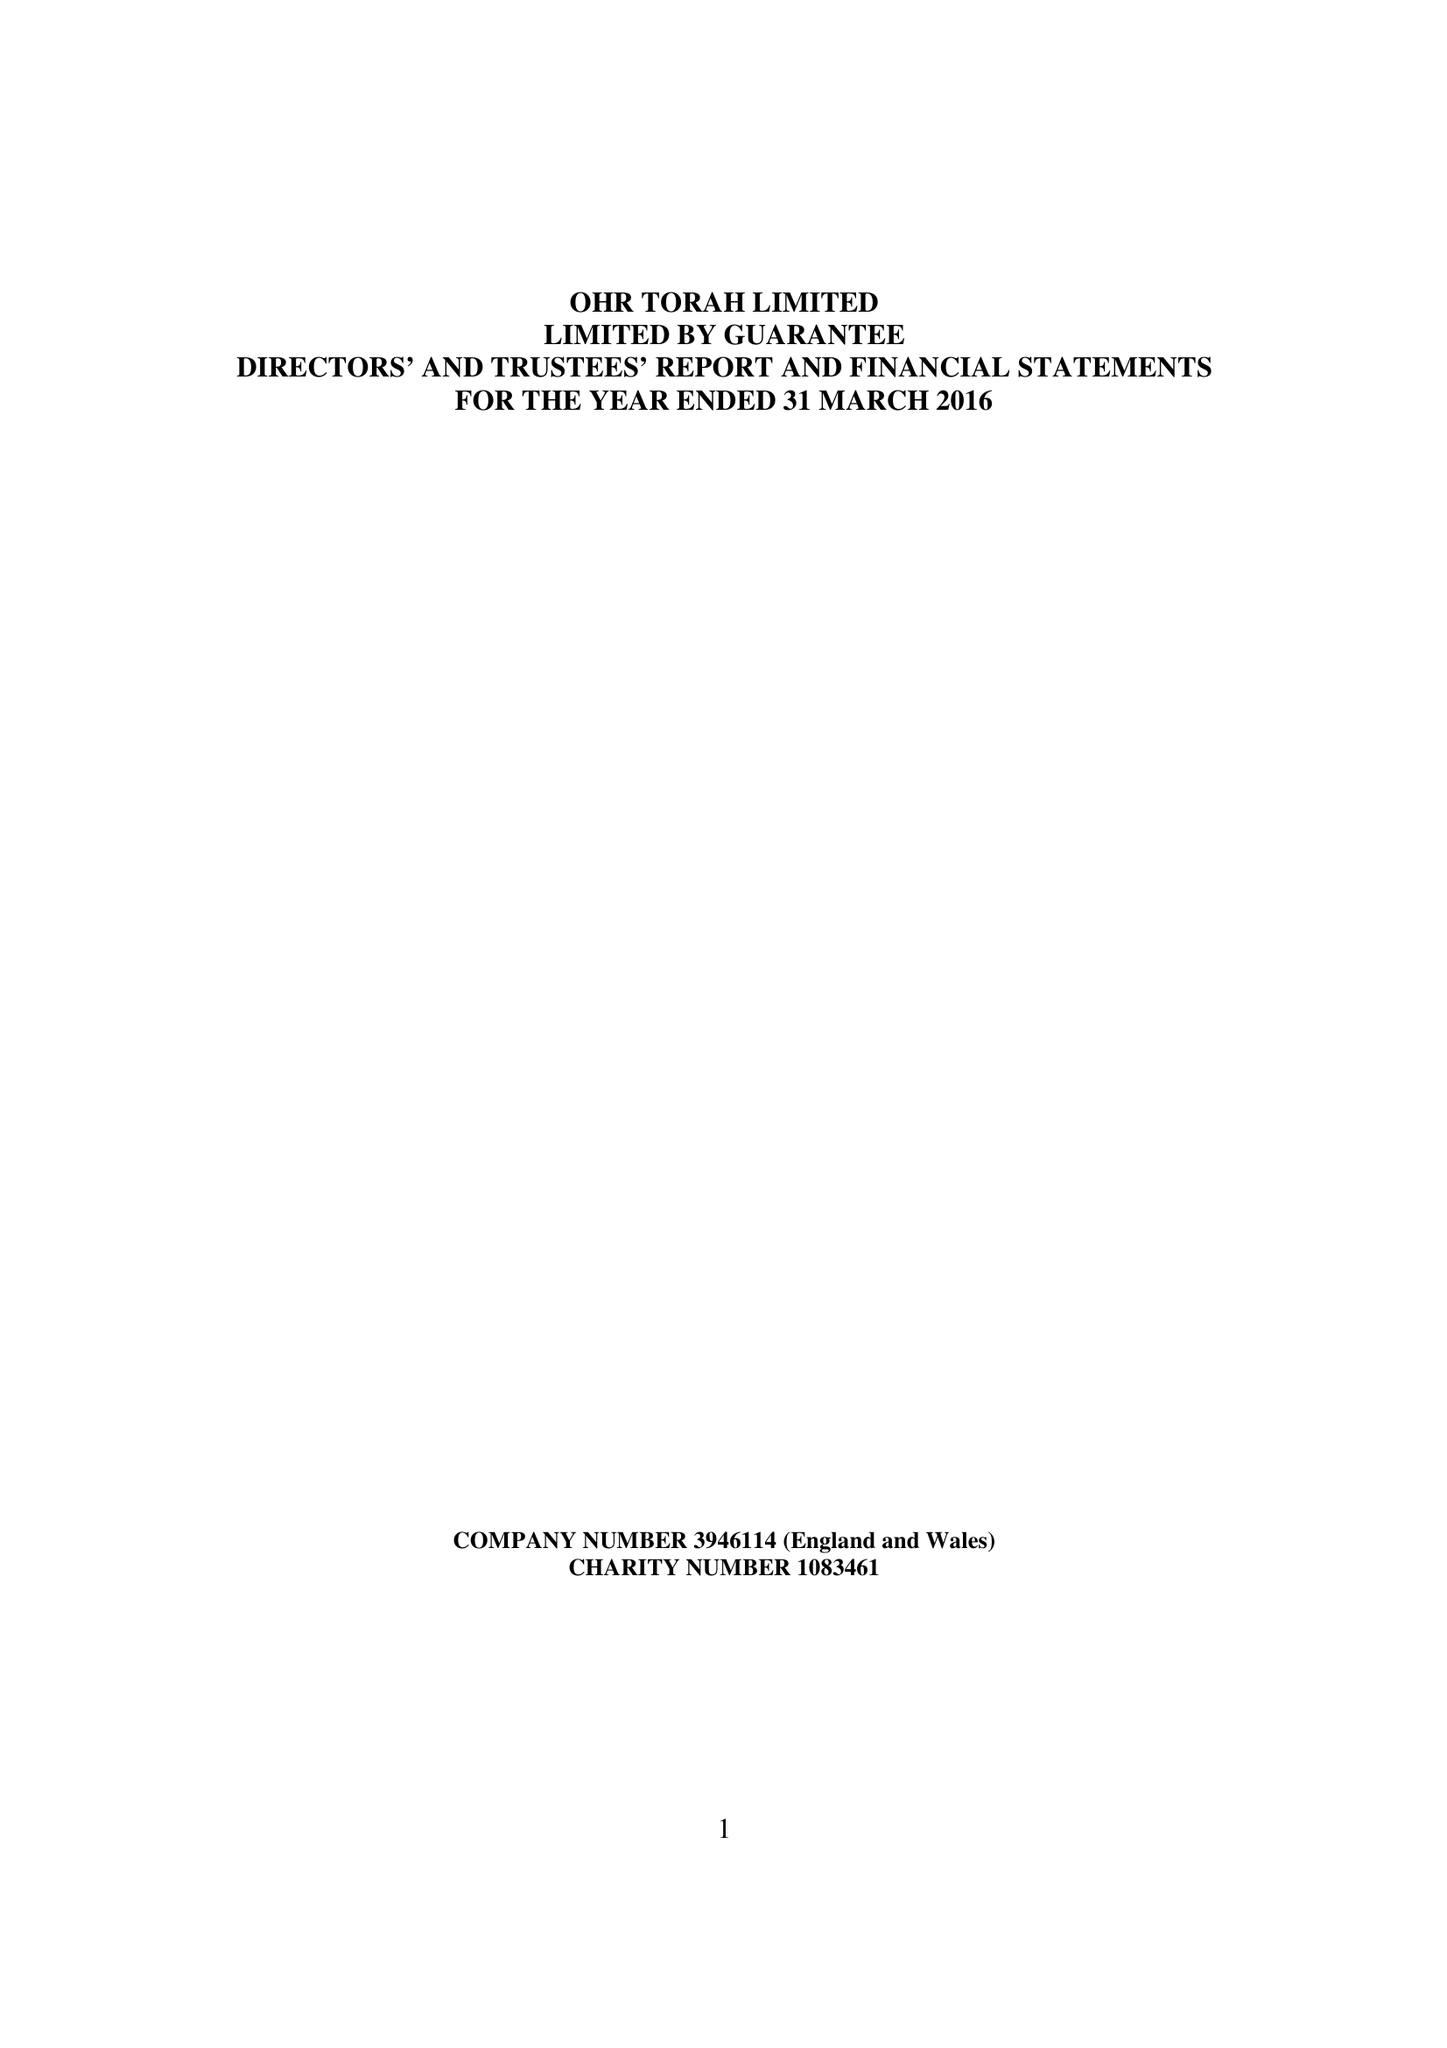What is the value for the charity_name?
Answer the question using a single word or phrase. Ohr Torah Ltd. 